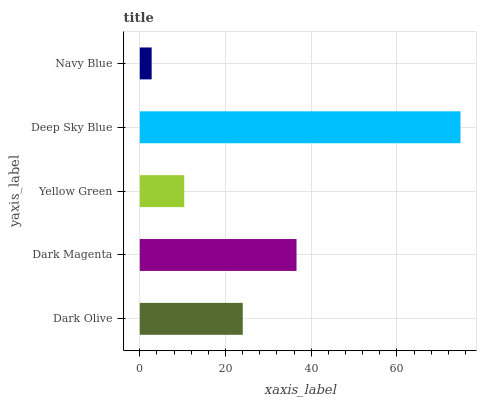Is Navy Blue the minimum?
Answer yes or no. Yes. Is Deep Sky Blue the maximum?
Answer yes or no. Yes. Is Dark Magenta the minimum?
Answer yes or no. No. Is Dark Magenta the maximum?
Answer yes or no. No. Is Dark Magenta greater than Dark Olive?
Answer yes or no. Yes. Is Dark Olive less than Dark Magenta?
Answer yes or no. Yes. Is Dark Olive greater than Dark Magenta?
Answer yes or no. No. Is Dark Magenta less than Dark Olive?
Answer yes or no. No. Is Dark Olive the high median?
Answer yes or no. Yes. Is Dark Olive the low median?
Answer yes or no. Yes. Is Dark Magenta the high median?
Answer yes or no. No. Is Deep Sky Blue the low median?
Answer yes or no. No. 